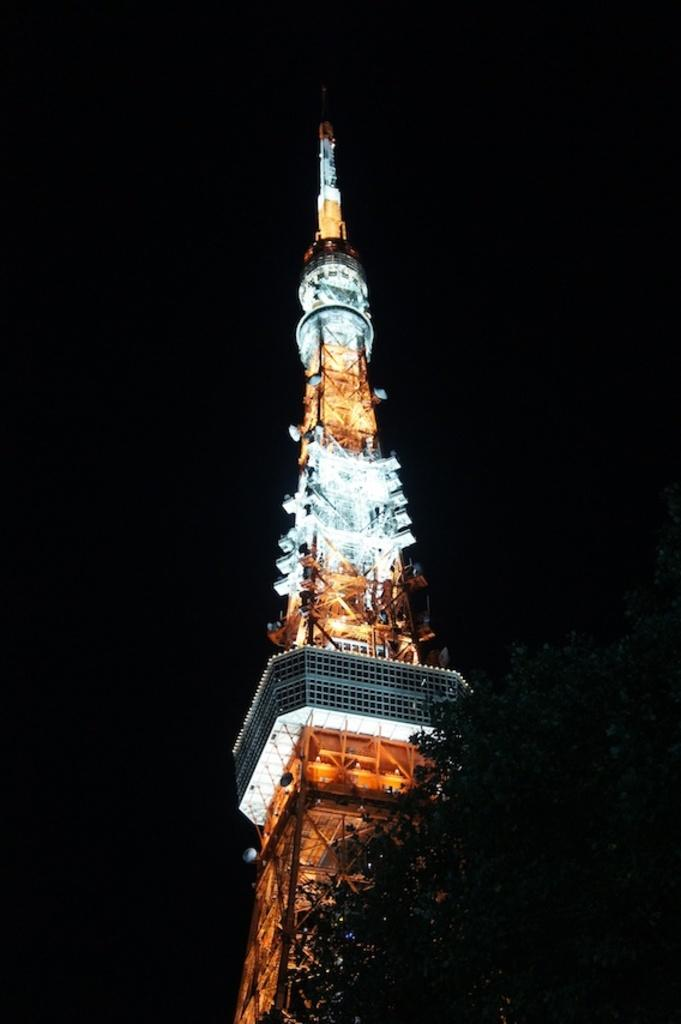What is the main structure in the image? There is a tower in the image. What can be seen illuminated in the image? There are lights visible in the image. How would you describe the overall appearance of the image? The background of the image is dark. What type of mine is depicted in the image? There is no mine present in the image; it features a tower and lights. What attempt is being made in the image? There is no attempt being made in the image; it is a static representation of a tower and lights. 